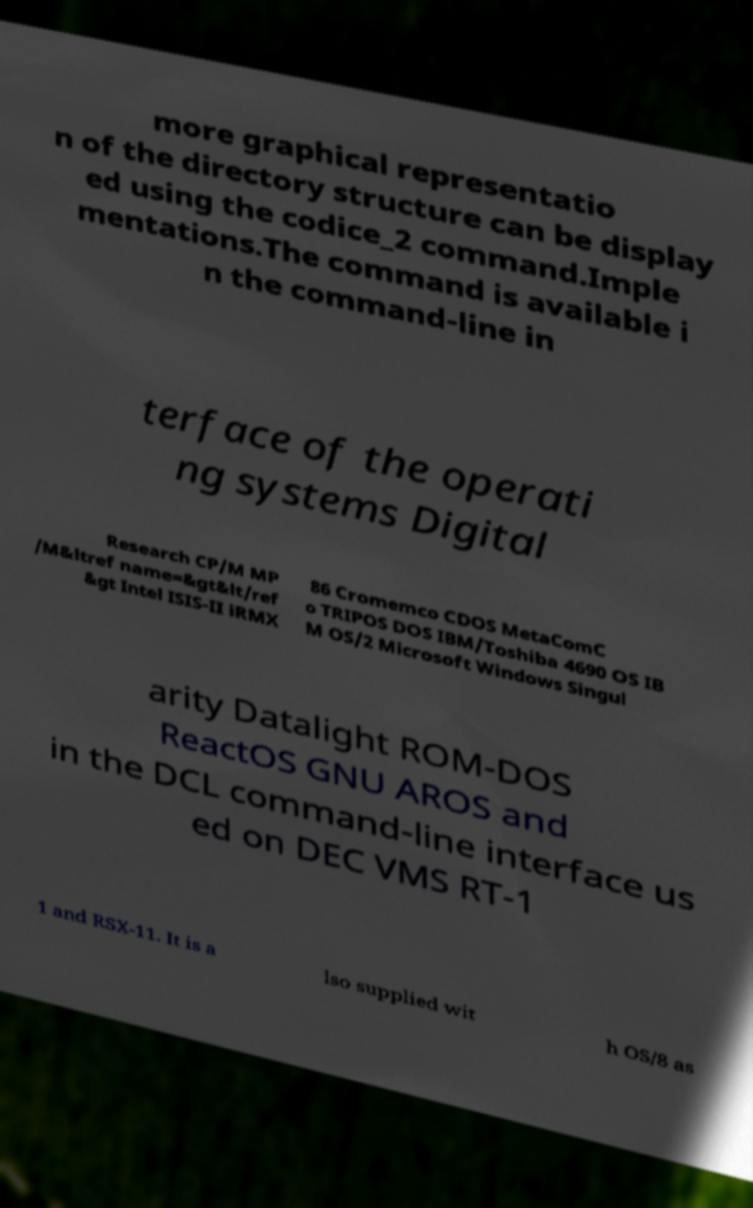Could you extract and type out the text from this image? more graphical representatio n of the directory structure can be display ed using the codice_2 command.Imple mentations.The command is available i n the command-line in terface of the operati ng systems Digital Research CP/M MP /M&ltref name=&gt&lt/ref &gt Intel ISIS-II iRMX 86 Cromemco CDOS MetaComC o TRIPOS DOS IBM/Toshiba 4690 OS IB M OS/2 Microsoft Windows Singul arity Datalight ROM-DOS ReactOS GNU AROS and in the DCL command-line interface us ed on DEC VMS RT-1 1 and RSX-11. It is a lso supplied wit h OS/8 as 